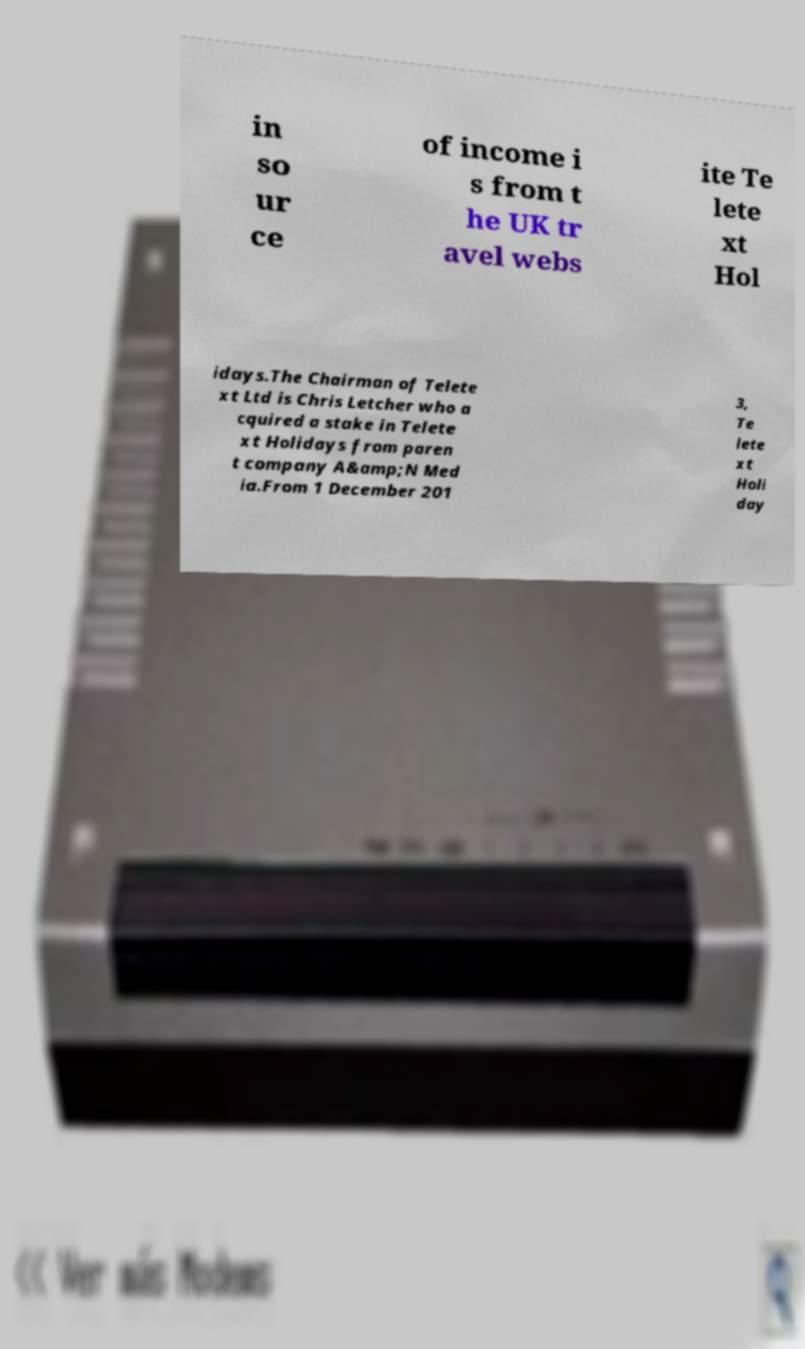Please read and relay the text visible in this image. What does it say? in so ur ce of income i s from t he UK tr avel webs ite Te lete xt Hol idays.The Chairman of Telete xt Ltd is Chris Letcher who a cquired a stake in Telete xt Holidays from paren t company A&amp;N Med ia.From 1 December 201 3, Te lete xt Holi day 